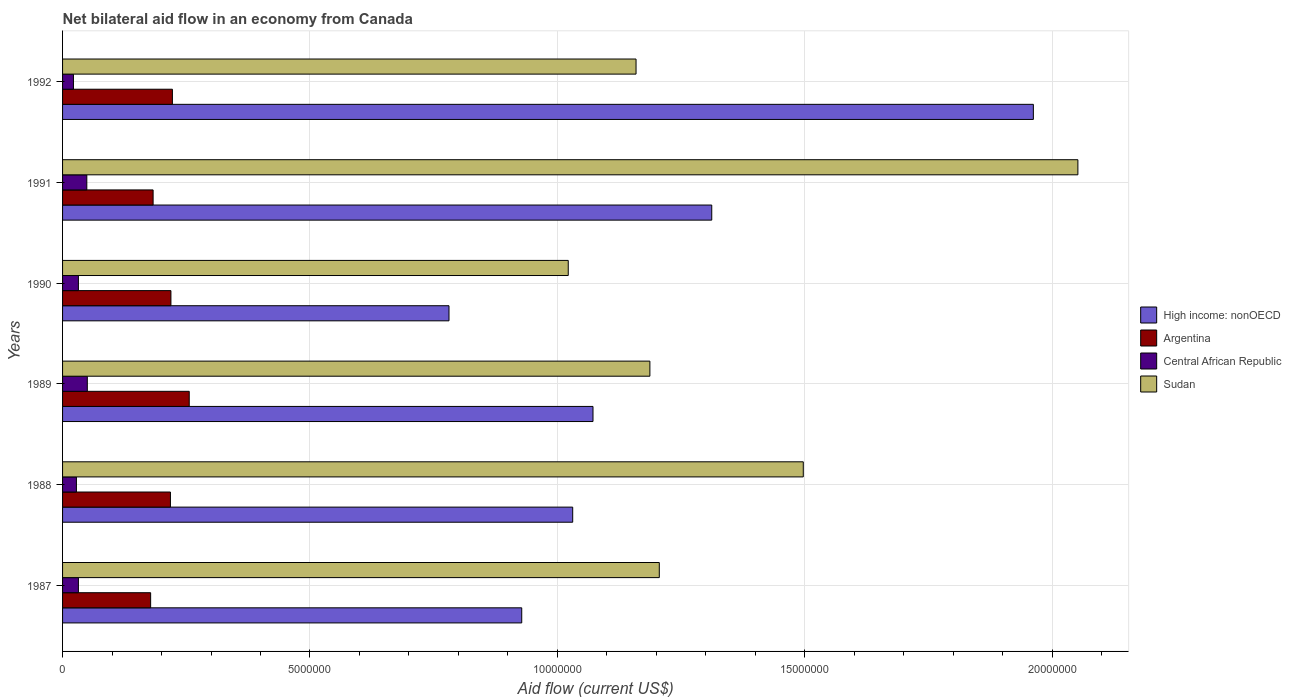How many groups of bars are there?
Give a very brief answer. 6. Are the number of bars on each tick of the Y-axis equal?
Provide a short and direct response. Yes. How many bars are there on the 3rd tick from the top?
Ensure brevity in your answer.  4. How many bars are there on the 4th tick from the bottom?
Offer a very short reply. 4. What is the label of the 2nd group of bars from the top?
Keep it short and to the point. 1991. In how many cases, is the number of bars for a given year not equal to the number of legend labels?
Provide a short and direct response. 0. Across all years, what is the maximum net bilateral aid flow in Sudan?
Make the answer very short. 2.05e+07. Across all years, what is the minimum net bilateral aid flow in Argentina?
Your response must be concise. 1.78e+06. In which year was the net bilateral aid flow in High income: nonOECD maximum?
Make the answer very short. 1992. What is the total net bilateral aid flow in Central African Republic in the graph?
Ensure brevity in your answer.  2.13e+06. What is the difference between the net bilateral aid flow in High income: nonOECD in 1987 and that in 1988?
Ensure brevity in your answer.  -1.03e+06. What is the difference between the net bilateral aid flow in Argentina in 1987 and the net bilateral aid flow in Sudan in 1988?
Ensure brevity in your answer.  -1.32e+07. What is the average net bilateral aid flow in Central African Republic per year?
Provide a short and direct response. 3.55e+05. In the year 1989, what is the difference between the net bilateral aid flow in High income: nonOECD and net bilateral aid flow in Argentina?
Your answer should be very brief. 8.16e+06. In how many years, is the net bilateral aid flow in Argentina greater than 5000000 US$?
Make the answer very short. 0. What is the ratio of the net bilateral aid flow in Sudan in 1988 to that in 1989?
Your answer should be compact. 1.26. Is the net bilateral aid flow in Sudan in 1987 less than that in 1992?
Offer a terse response. No. What is the difference between the highest and the second highest net bilateral aid flow in Sudan?
Offer a very short reply. 5.55e+06. What is the difference between the highest and the lowest net bilateral aid flow in Central African Republic?
Offer a very short reply. 2.80e+05. In how many years, is the net bilateral aid flow in Argentina greater than the average net bilateral aid flow in Argentina taken over all years?
Provide a succinct answer. 4. Is the sum of the net bilateral aid flow in Central African Republic in 1987 and 1991 greater than the maximum net bilateral aid flow in Sudan across all years?
Offer a very short reply. No. What does the 3rd bar from the bottom in 1991 represents?
Ensure brevity in your answer.  Central African Republic. How many years are there in the graph?
Make the answer very short. 6. Are the values on the major ticks of X-axis written in scientific E-notation?
Offer a terse response. No. What is the title of the graph?
Offer a very short reply. Net bilateral aid flow in an economy from Canada. What is the label or title of the Y-axis?
Make the answer very short. Years. What is the Aid flow (current US$) of High income: nonOECD in 1987?
Your answer should be very brief. 9.28e+06. What is the Aid flow (current US$) in Argentina in 1987?
Provide a short and direct response. 1.78e+06. What is the Aid flow (current US$) in Sudan in 1987?
Ensure brevity in your answer.  1.21e+07. What is the Aid flow (current US$) of High income: nonOECD in 1988?
Your answer should be compact. 1.03e+07. What is the Aid flow (current US$) of Argentina in 1988?
Your answer should be very brief. 2.18e+06. What is the Aid flow (current US$) of Central African Republic in 1988?
Your answer should be very brief. 2.80e+05. What is the Aid flow (current US$) in Sudan in 1988?
Provide a succinct answer. 1.50e+07. What is the Aid flow (current US$) in High income: nonOECD in 1989?
Give a very brief answer. 1.07e+07. What is the Aid flow (current US$) of Argentina in 1989?
Provide a short and direct response. 2.56e+06. What is the Aid flow (current US$) in Sudan in 1989?
Keep it short and to the point. 1.19e+07. What is the Aid flow (current US$) in High income: nonOECD in 1990?
Your answer should be compact. 7.81e+06. What is the Aid flow (current US$) of Argentina in 1990?
Provide a short and direct response. 2.19e+06. What is the Aid flow (current US$) in Central African Republic in 1990?
Offer a terse response. 3.20e+05. What is the Aid flow (current US$) in Sudan in 1990?
Ensure brevity in your answer.  1.02e+07. What is the Aid flow (current US$) in High income: nonOECD in 1991?
Your answer should be very brief. 1.31e+07. What is the Aid flow (current US$) of Argentina in 1991?
Give a very brief answer. 1.83e+06. What is the Aid flow (current US$) in Sudan in 1991?
Provide a short and direct response. 2.05e+07. What is the Aid flow (current US$) in High income: nonOECD in 1992?
Offer a very short reply. 1.96e+07. What is the Aid flow (current US$) in Argentina in 1992?
Ensure brevity in your answer.  2.22e+06. What is the Aid flow (current US$) in Sudan in 1992?
Your response must be concise. 1.16e+07. Across all years, what is the maximum Aid flow (current US$) in High income: nonOECD?
Your answer should be very brief. 1.96e+07. Across all years, what is the maximum Aid flow (current US$) of Argentina?
Keep it short and to the point. 2.56e+06. Across all years, what is the maximum Aid flow (current US$) of Central African Republic?
Your response must be concise. 5.00e+05. Across all years, what is the maximum Aid flow (current US$) in Sudan?
Give a very brief answer. 2.05e+07. Across all years, what is the minimum Aid flow (current US$) of High income: nonOECD?
Your answer should be very brief. 7.81e+06. Across all years, what is the minimum Aid flow (current US$) in Argentina?
Offer a terse response. 1.78e+06. Across all years, what is the minimum Aid flow (current US$) of Central African Republic?
Provide a succinct answer. 2.20e+05. Across all years, what is the minimum Aid flow (current US$) of Sudan?
Keep it short and to the point. 1.02e+07. What is the total Aid flow (current US$) in High income: nonOECD in the graph?
Provide a short and direct response. 7.09e+07. What is the total Aid flow (current US$) in Argentina in the graph?
Give a very brief answer. 1.28e+07. What is the total Aid flow (current US$) of Central African Republic in the graph?
Your answer should be compact. 2.13e+06. What is the total Aid flow (current US$) in Sudan in the graph?
Your answer should be very brief. 8.12e+07. What is the difference between the Aid flow (current US$) in High income: nonOECD in 1987 and that in 1988?
Provide a short and direct response. -1.03e+06. What is the difference between the Aid flow (current US$) of Argentina in 1987 and that in 1988?
Your answer should be very brief. -4.00e+05. What is the difference between the Aid flow (current US$) in Sudan in 1987 and that in 1988?
Keep it short and to the point. -2.91e+06. What is the difference between the Aid flow (current US$) of High income: nonOECD in 1987 and that in 1989?
Give a very brief answer. -1.44e+06. What is the difference between the Aid flow (current US$) of Argentina in 1987 and that in 1989?
Offer a terse response. -7.80e+05. What is the difference between the Aid flow (current US$) of Central African Republic in 1987 and that in 1989?
Provide a short and direct response. -1.80e+05. What is the difference between the Aid flow (current US$) in High income: nonOECD in 1987 and that in 1990?
Ensure brevity in your answer.  1.47e+06. What is the difference between the Aid flow (current US$) of Argentina in 1987 and that in 1990?
Ensure brevity in your answer.  -4.10e+05. What is the difference between the Aid flow (current US$) in Sudan in 1987 and that in 1990?
Offer a terse response. 1.84e+06. What is the difference between the Aid flow (current US$) of High income: nonOECD in 1987 and that in 1991?
Provide a succinct answer. -3.84e+06. What is the difference between the Aid flow (current US$) in Argentina in 1987 and that in 1991?
Ensure brevity in your answer.  -5.00e+04. What is the difference between the Aid flow (current US$) of Sudan in 1987 and that in 1991?
Your answer should be very brief. -8.46e+06. What is the difference between the Aid flow (current US$) in High income: nonOECD in 1987 and that in 1992?
Offer a terse response. -1.03e+07. What is the difference between the Aid flow (current US$) in Argentina in 1987 and that in 1992?
Your answer should be very brief. -4.40e+05. What is the difference between the Aid flow (current US$) of Central African Republic in 1987 and that in 1992?
Offer a very short reply. 1.00e+05. What is the difference between the Aid flow (current US$) in High income: nonOECD in 1988 and that in 1989?
Offer a terse response. -4.10e+05. What is the difference between the Aid flow (current US$) in Argentina in 1988 and that in 1989?
Your answer should be compact. -3.80e+05. What is the difference between the Aid flow (current US$) of Sudan in 1988 and that in 1989?
Offer a very short reply. 3.10e+06. What is the difference between the Aid flow (current US$) of High income: nonOECD in 1988 and that in 1990?
Offer a very short reply. 2.50e+06. What is the difference between the Aid flow (current US$) of Argentina in 1988 and that in 1990?
Keep it short and to the point. -10000. What is the difference between the Aid flow (current US$) of Sudan in 1988 and that in 1990?
Make the answer very short. 4.75e+06. What is the difference between the Aid flow (current US$) of High income: nonOECD in 1988 and that in 1991?
Give a very brief answer. -2.81e+06. What is the difference between the Aid flow (current US$) in Argentina in 1988 and that in 1991?
Provide a short and direct response. 3.50e+05. What is the difference between the Aid flow (current US$) of Sudan in 1988 and that in 1991?
Offer a terse response. -5.55e+06. What is the difference between the Aid flow (current US$) in High income: nonOECD in 1988 and that in 1992?
Your answer should be compact. -9.31e+06. What is the difference between the Aid flow (current US$) of Argentina in 1988 and that in 1992?
Your response must be concise. -4.00e+04. What is the difference between the Aid flow (current US$) in Sudan in 1988 and that in 1992?
Keep it short and to the point. 3.38e+06. What is the difference between the Aid flow (current US$) in High income: nonOECD in 1989 and that in 1990?
Ensure brevity in your answer.  2.91e+06. What is the difference between the Aid flow (current US$) in Argentina in 1989 and that in 1990?
Provide a short and direct response. 3.70e+05. What is the difference between the Aid flow (current US$) in Sudan in 1989 and that in 1990?
Make the answer very short. 1.65e+06. What is the difference between the Aid flow (current US$) in High income: nonOECD in 1989 and that in 1991?
Ensure brevity in your answer.  -2.40e+06. What is the difference between the Aid flow (current US$) of Argentina in 1989 and that in 1991?
Keep it short and to the point. 7.30e+05. What is the difference between the Aid flow (current US$) in Sudan in 1989 and that in 1991?
Keep it short and to the point. -8.65e+06. What is the difference between the Aid flow (current US$) of High income: nonOECD in 1989 and that in 1992?
Provide a short and direct response. -8.90e+06. What is the difference between the Aid flow (current US$) of Sudan in 1989 and that in 1992?
Provide a succinct answer. 2.80e+05. What is the difference between the Aid flow (current US$) of High income: nonOECD in 1990 and that in 1991?
Your response must be concise. -5.31e+06. What is the difference between the Aid flow (current US$) of Central African Republic in 1990 and that in 1991?
Provide a succinct answer. -1.70e+05. What is the difference between the Aid flow (current US$) of Sudan in 1990 and that in 1991?
Make the answer very short. -1.03e+07. What is the difference between the Aid flow (current US$) of High income: nonOECD in 1990 and that in 1992?
Keep it short and to the point. -1.18e+07. What is the difference between the Aid flow (current US$) of Argentina in 1990 and that in 1992?
Give a very brief answer. -3.00e+04. What is the difference between the Aid flow (current US$) of Central African Republic in 1990 and that in 1992?
Provide a short and direct response. 1.00e+05. What is the difference between the Aid flow (current US$) in Sudan in 1990 and that in 1992?
Offer a terse response. -1.37e+06. What is the difference between the Aid flow (current US$) of High income: nonOECD in 1991 and that in 1992?
Offer a terse response. -6.50e+06. What is the difference between the Aid flow (current US$) of Argentina in 1991 and that in 1992?
Your response must be concise. -3.90e+05. What is the difference between the Aid flow (current US$) of Central African Republic in 1991 and that in 1992?
Keep it short and to the point. 2.70e+05. What is the difference between the Aid flow (current US$) of Sudan in 1991 and that in 1992?
Provide a succinct answer. 8.93e+06. What is the difference between the Aid flow (current US$) of High income: nonOECD in 1987 and the Aid flow (current US$) of Argentina in 1988?
Make the answer very short. 7.10e+06. What is the difference between the Aid flow (current US$) of High income: nonOECD in 1987 and the Aid flow (current US$) of Central African Republic in 1988?
Offer a terse response. 9.00e+06. What is the difference between the Aid flow (current US$) of High income: nonOECD in 1987 and the Aid flow (current US$) of Sudan in 1988?
Offer a terse response. -5.69e+06. What is the difference between the Aid flow (current US$) of Argentina in 1987 and the Aid flow (current US$) of Central African Republic in 1988?
Offer a terse response. 1.50e+06. What is the difference between the Aid flow (current US$) in Argentina in 1987 and the Aid flow (current US$) in Sudan in 1988?
Your response must be concise. -1.32e+07. What is the difference between the Aid flow (current US$) in Central African Republic in 1987 and the Aid flow (current US$) in Sudan in 1988?
Keep it short and to the point. -1.46e+07. What is the difference between the Aid flow (current US$) of High income: nonOECD in 1987 and the Aid flow (current US$) of Argentina in 1989?
Offer a very short reply. 6.72e+06. What is the difference between the Aid flow (current US$) of High income: nonOECD in 1987 and the Aid flow (current US$) of Central African Republic in 1989?
Your answer should be very brief. 8.78e+06. What is the difference between the Aid flow (current US$) of High income: nonOECD in 1987 and the Aid flow (current US$) of Sudan in 1989?
Give a very brief answer. -2.59e+06. What is the difference between the Aid flow (current US$) of Argentina in 1987 and the Aid flow (current US$) of Central African Republic in 1989?
Your answer should be very brief. 1.28e+06. What is the difference between the Aid flow (current US$) of Argentina in 1987 and the Aid flow (current US$) of Sudan in 1989?
Make the answer very short. -1.01e+07. What is the difference between the Aid flow (current US$) of Central African Republic in 1987 and the Aid flow (current US$) of Sudan in 1989?
Your answer should be very brief. -1.16e+07. What is the difference between the Aid flow (current US$) of High income: nonOECD in 1987 and the Aid flow (current US$) of Argentina in 1990?
Make the answer very short. 7.09e+06. What is the difference between the Aid flow (current US$) in High income: nonOECD in 1987 and the Aid flow (current US$) in Central African Republic in 1990?
Your response must be concise. 8.96e+06. What is the difference between the Aid flow (current US$) of High income: nonOECD in 1987 and the Aid flow (current US$) of Sudan in 1990?
Ensure brevity in your answer.  -9.40e+05. What is the difference between the Aid flow (current US$) in Argentina in 1987 and the Aid flow (current US$) in Central African Republic in 1990?
Keep it short and to the point. 1.46e+06. What is the difference between the Aid flow (current US$) in Argentina in 1987 and the Aid flow (current US$) in Sudan in 1990?
Keep it short and to the point. -8.44e+06. What is the difference between the Aid flow (current US$) in Central African Republic in 1987 and the Aid flow (current US$) in Sudan in 1990?
Provide a short and direct response. -9.90e+06. What is the difference between the Aid flow (current US$) of High income: nonOECD in 1987 and the Aid flow (current US$) of Argentina in 1991?
Ensure brevity in your answer.  7.45e+06. What is the difference between the Aid flow (current US$) of High income: nonOECD in 1987 and the Aid flow (current US$) of Central African Republic in 1991?
Make the answer very short. 8.79e+06. What is the difference between the Aid flow (current US$) in High income: nonOECD in 1987 and the Aid flow (current US$) in Sudan in 1991?
Your answer should be compact. -1.12e+07. What is the difference between the Aid flow (current US$) in Argentina in 1987 and the Aid flow (current US$) in Central African Republic in 1991?
Keep it short and to the point. 1.29e+06. What is the difference between the Aid flow (current US$) in Argentina in 1987 and the Aid flow (current US$) in Sudan in 1991?
Keep it short and to the point. -1.87e+07. What is the difference between the Aid flow (current US$) of Central African Republic in 1987 and the Aid flow (current US$) of Sudan in 1991?
Offer a terse response. -2.02e+07. What is the difference between the Aid flow (current US$) in High income: nonOECD in 1987 and the Aid flow (current US$) in Argentina in 1992?
Make the answer very short. 7.06e+06. What is the difference between the Aid flow (current US$) in High income: nonOECD in 1987 and the Aid flow (current US$) in Central African Republic in 1992?
Ensure brevity in your answer.  9.06e+06. What is the difference between the Aid flow (current US$) of High income: nonOECD in 1987 and the Aid flow (current US$) of Sudan in 1992?
Offer a terse response. -2.31e+06. What is the difference between the Aid flow (current US$) in Argentina in 1987 and the Aid flow (current US$) in Central African Republic in 1992?
Your answer should be compact. 1.56e+06. What is the difference between the Aid flow (current US$) in Argentina in 1987 and the Aid flow (current US$) in Sudan in 1992?
Make the answer very short. -9.81e+06. What is the difference between the Aid flow (current US$) in Central African Republic in 1987 and the Aid flow (current US$) in Sudan in 1992?
Offer a terse response. -1.13e+07. What is the difference between the Aid flow (current US$) of High income: nonOECD in 1988 and the Aid flow (current US$) of Argentina in 1989?
Give a very brief answer. 7.75e+06. What is the difference between the Aid flow (current US$) in High income: nonOECD in 1988 and the Aid flow (current US$) in Central African Republic in 1989?
Your answer should be compact. 9.81e+06. What is the difference between the Aid flow (current US$) of High income: nonOECD in 1988 and the Aid flow (current US$) of Sudan in 1989?
Provide a succinct answer. -1.56e+06. What is the difference between the Aid flow (current US$) in Argentina in 1988 and the Aid flow (current US$) in Central African Republic in 1989?
Keep it short and to the point. 1.68e+06. What is the difference between the Aid flow (current US$) of Argentina in 1988 and the Aid flow (current US$) of Sudan in 1989?
Provide a short and direct response. -9.69e+06. What is the difference between the Aid flow (current US$) of Central African Republic in 1988 and the Aid flow (current US$) of Sudan in 1989?
Make the answer very short. -1.16e+07. What is the difference between the Aid flow (current US$) in High income: nonOECD in 1988 and the Aid flow (current US$) in Argentina in 1990?
Provide a short and direct response. 8.12e+06. What is the difference between the Aid flow (current US$) in High income: nonOECD in 1988 and the Aid flow (current US$) in Central African Republic in 1990?
Ensure brevity in your answer.  9.99e+06. What is the difference between the Aid flow (current US$) in High income: nonOECD in 1988 and the Aid flow (current US$) in Sudan in 1990?
Your answer should be very brief. 9.00e+04. What is the difference between the Aid flow (current US$) of Argentina in 1988 and the Aid flow (current US$) of Central African Republic in 1990?
Make the answer very short. 1.86e+06. What is the difference between the Aid flow (current US$) in Argentina in 1988 and the Aid flow (current US$) in Sudan in 1990?
Provide a short and direct response. -8.04e+06. What is the difference between the Aid flow (current US$) of Central African Republic in 1988 and the Aid flow (current US$) of Sudan in 1990?
Offer a very short reply. -9.94e+06. What is the difference between the Aid flow (current US$) in High income: nonOECD in 1988 and the Aid flow (current US$) in Argentina in 1991?
Your answer should be very brief. 8.48e+06. What is the difference between the Aid flow (current US$) in High income: nonOECD in 1988 and the Aid flow (current US$) in Central African Republic in 1991?
Keep it short and to the point. 9.82e+06. What is the difference between the Aid flow (current US$) in High income: nonOECD in 1988 and the Aid flow (current US$) in Sudan in 1991?
Keep it short and to the point. -1.02e+07. What is the difference between the Aid flow (current US$) of Argentina in 1988 and the Aid flow (current US$) of Central African Republic in 1991?
Offer a very short reply. 1.69e+06. What is the difference between the Aid flow (current US$) of Argentina in 1988 and the Aid flow (current US$) of Sudan in 1991?
Offer a terse response. -1.83e+07. What is the difference between the Aid flow (current US$) of Central African Republic in 1988 and the Aid flow (current US$) of Sudan in 1991?
Provide a succinct answer. -2.02e+07. What is the difference between the Aid flow (current US$) in High income: nonOECD in 1988 and the Aid flow (current US$) in Argentina in 1992?
Offer a terse response. 8.09e+06. What is the difference between the Aid flow (current US$) in High income: nonOECD in 1988 and the Aid flow (current US$) in Central African Republic in 1992?
Offer a very short reply. 1.01e+07. What is the difference between the Aid flow (current US$) of High income: nonOECD in 1988 and the Aid flow (current US$) of Sudan in 1992?
Keep it short and to the point. -1.28e+06. What is the difference between the Aid flow (current US$) in Argentina in 1988 and the Aid flow (current US$) in Central African Republic in 1992?
Your answer should be very brief. 1.96e+06. What is the difference between the Aid flow (current US$) in Argentina in 1988 and the Aid flow (current US$) in Sudan in 1992?
Offer a very short reply. -9.41e+06. What is the difference between the Aid flow (current US$) of Central African Republic in 1988 and the Aid flow (current US$) of Sudan in 1992?
Provide a short and direct response. -1.13e+07. What is the difference between the Aid flow (current US$) in High income: nonOECD in 1989 and the Aid flow (current US$) in Argentina in 1990?
Offer a terse response. 8.53e+06. What is the difference between the Aid flow (current US$) of High income: nonOECD in 1989 and the Aid flow (current US$) of Central African Republic in 1990?
Ensure brevity in your answer.  1.04e+07. What is the difference between the Aid flow (current US$) of Argentina in 1989 and the Aid flow (current US$) of Central African Republic in 1990?
Provide a short and direct response. 2.24e+06. What is the difference between the Aid flow (current US$) of Argentina in 1989 and the Aid flow (current US$) of Sudan in 1990?
Make the answer very short. -7.66e+06. What is the difference between the Aid flow (current US$) in Central African Republic in 1989 and the Aid flow (current US$) in Sudan in 1990?
Offer a very short reply. -9.72e+06. What is the difference between the Aid flow (current US$) in High income: nonOECD in 1989 and the Aid flow (current US$) in Argentina in 1991?
Offer a very short reply. 8.89e+06. What is the difference between the Aid flow (current US$) in High income: nonOECD in 1989 and the Aid flow (current US$) in Central African Republic in 1991?
Provide a succinct answer. 1.02e+07. What is the difference between the Aid flow (current US$) of High income: nonOECD in 1989 and the Aid flow (current US$) of Sudan in 1991?
Your answer should be very brief. -9.80e+06. What is the difference between the Aid flow (current US$) in Argentina in 1989 and the Aid flow (current US$) in Central African Republic in 1991?
Your answer should be compact. 2.07e+06. What is the difference between the Aid flow (current US$) of Argentina in 1989 and the Aid flow (current US$) of Sudan in 1991?
Your response must be concise. -1.80e+07. What is the difference between the Aid flow (current US$) of Central African Republic in 1989 and the Aid flow (current US$) of Sudan in 1991?
Ensure brevity in your answer.  -2.00e+07. What is the difference between the Aid flow (current US$) of High income: nonOECD in 1989 and the Aid flow (current US$) of Argentina in 1992?
Make the answer very short. 8.50e+06. What is the difference between the Aid flow (current US$) in High income: nonOECD in 1989 and the Aid flow (current US$) in Central African Republic in 1992?
Offer a terse response. 1.05e+07. What is the difference between the Aid flow (current US$) in High income: nonOECD in 1989 and the Aid flow (current US$) in Sudan in 1992?
Give a very brief answer. -8.70e+05. What is the difference between the Aid flow (current US$) of Argentina in 1989 and the Aid flow (current US$) of Central African Republic in 1992?
Make the answer very short. 2.34e+06. What is the difference between the Aid flow (current US$) in Argentina in 1989 and the Aid flow (current US$) in Sudan in 1992?
Your answer should be very brief. -9.03e+06. What is the difference between the Aid flow (current US$) in Central African Republic in 1989 and the Aid flow (current US$) in Sudan in 1992?
Make the answer very short. -1.11e+07. What is the difference between the Aid flow (current US$) of High income: nonOECD in 1990 and the Aid flow (current US$) of Argentina in 1991?
Offer a terse response. 5.98e+06. What is the difference between the Aid flow (current US$) in High income: nonOECD in 1990 and the Aid flow (current US$) in Central African Republic in 1991?
Offer a very short reply. 7.32e+06. What is the difference between the Aid flow (current US$) of High income: nonOECD in 1990 and the Aid flow (current US$) of Sudan in 1991?
Your response must be concise. -1.27e+07. What is the difference between the Aid flow (current US$) in Argentina in 1990 and the Aid flow (current US$) in Central African Republic in 1991?
Give a very brief answer. 1.70e+06. What is the difference between the Aid flow (current US$) in Argentina in 1990 and the Aid flow (current US$) in Sudan in 1991?
Ensure brevity in your answer.  -1.83e+07. What is the difference between the Aid flow (current US$) of Central African Republic in 1990 and the Aid flow (current US$) of Sudan in 1991?
Make the answer very short. -2.02e+07. What is the difference between the Aid flow (current US$) in High income: nonOECD in 1990 and the Aid flow (current US$) in Argentina in 1992?
Make the answer very short. 5.59e+06. What is the difference between the Aid flow (current US$) in High income: nonOECD in 1990 and the Aid flow (current US$) in Central African Republic in 1992?
Your response must be concise. 7.59e+06. What is the difference between the Aid flow (current US$) in High income: nonOECD in 1990 and the Aid flow (current US$) in Sudan in 1992?
Provide a short and direct response. -3.78e+06. What is the difference between the Aid flow (current US$) of Argentina in 1990 and the Aid flow (current US$) of Central African Republic in 1992?
Your response must be concise. 1.97e+06. What is the difference between the Aid flow (current US$) in Argentina in 1990 and the Aid flow (current US$) in Sudan in 1992?
Give a very brief answer. -9.40e+06. What is the difference between the Aid flow (current US$) in Central African Republic in 1990 and the Aid flow (current US$) in Sudan in 1992?
Make the answer very short. -1.13e+07. What is the difference between the Aid flow (current US$) of High income: nonOECD in 1991 and the Aid flow (current US$) of Argentina in 1992?
Give a very brief answer. 1.09e+07. What is the difference between the Aid flow (current US$) in High income: nonOECD in 1991 and the Aid flow (current US$) in Central African Republic in 1992?
Give a very brief answer. 1.29e+07. What is the difference between the Aid flow (current US$) of High income: nonOECD in 1991 and the Aid flow (current US$) of Sudan in 1992?
Make the answer very short. 1.53e+06. What is the difference between the Aid flow (current US$) of Argentina in 1991 and the Aid flow (current US$) of Central African Republic in 1992?
Keep it short and to the point. 1.61e+06. What is the difference between the Aid flow (current US$) of Argentina in 1991 and the Aid flow (current US$) of Sudan in 1992?
Make the answer very short. -9.76e+06. What is the difference between the Aid flow (current US$) of Central African Republic in 1991 and the Aid flow (current US$) of Sudan in 1992?
Your answer should be very brief. -1.11e+07. What is the average Aid flow (current US$) of High income: nonOECD per year?
Keep it short and to the point. 1.18e+07. What is the average Aid flow (current US$) of Argentina per year?
Give a very brief answer. 2.13e+06. What is the average Aid flow (current US$) of Central African Republic per year?
Your answer should be compact. 3.55e+05. What is the average Aid flow (current US$) in Sudan per year?
Keep it short and to the point. 1.35e+07. In the year 1987, what is the difference between the Aid flow (current US$) in High income: nonOECD and Aid flow (current US$) in Argentina?
Give a very brief answer. 7.50e+06. In the year 1987, what is the difference between the Aid flow (current US$) of High income: nonOECD and Aid flow (current US$) of Central African Republic?
Your response must be concise. 8.96e+06. In the year 1987, what is the difference between the Aid flow (current US$) in High income: nonOECD and Aid flow (current US$) in Sudan?
Offer a terse response. -2.78e+06. In the year 1987, what is the difference between the Aid flow (current US$) in Argentina and Aid flow (current US$) in Central African Republic?
Make the answer very short. 1.46e+06. In the year 1987, what is the difference between the Aid flow (current US$) of Argentina and Aid flow (current US$) of Sudan?
Offer a terse response. -1.03e+07. In the year 1987, what is the difference between the Aid flow (current US$) in Central African Republic and Aid flow (current US$) in Sudan?
Ensure brevity in your answer.  -1.17e+07. In the year 1988, what is the difference between the Aid flow (current US$) of High income: nonOECD and Aid flow (current US$) of Argentina?
Your response must be concise. 8.13e+06. In the year 1988, what is the difference between the Aid flow (current US$) in High income: nonOECD and Aid flow (current US$) in Central African Republic?
Ensure brevity in your answer.  1.00e+07. In the year 1988, what is the difference between the Aid flow (current US$) in High income: nonOECD and Aid flow (current US$) in Sudan?
Your answer should be very brief. -4.66e+06. In the year 1988, what is the difference between the Aid flow (current US$) in Argentina and Aid flow (current US$) in Central African Republic?
Give a very brief answer. 1.90e+06. In the year 1988, what is the difference between the Aid flow (current US$) of Argentina and Aid flow (current US$) of Sudan?
Your answer should be very brief. -1.28e+07. In the year 1988, what is the difference between the Aid flow (current US$) in Central African Republic and Aid flow (current US$) in Sudan?
Offer a terse response. -1.47e+07. In the year 1989, what is the difference between the Aid flow (current US$) of High income: nonOECD and Aid flow (current US$) of Argentina?
Your response must be concise. 8.16e+06. In the year 1989, what is the difference between the Aid flow (current US$) in High income: nonOECD and Aid flow (current US$) in Central African Republic?
Keep it short and to the point. 1.02e+07. In the year 1989, what is the difference between the Aid flow (current US$) in High income: nonOECD and Aid flow (current US$) in Sudan?
Ensure brevity in your answer.  -1.15e+06. In the year 1989, what is the difference between the Aid flow (current US$) in Argentina and Aid flow (current US$) in Central African Republic?
Provide a succinct answer. 2.06e+06. In the year 1989, what is the difference between the Aid flow (current US$) of Argentina and Aid flow (current US$) of Sudan?
Your response must be concise. -9.31e+06. In the year 1989, what is the difference between the Aid flow (current US$) in Central African Republic and Aid flow (current US$) in Sudan?
Make the answer very short. -1.14e+07. In the year 1990, what is the difference between the Aid flow (current US$) in High income: nonOECD and Aid flow (current US$) in Argentina?
Offer a very short reply. 5.62e+06. In the year 1990, what is the difference between the Aid flow (current US$) in High income: nonOECD and Aid flow (current US$) in Central African Republic?
Offer a very short reply. 7.49e+06. In the year 1990, what is the difference between the Aid flow (current US$) of High income: nonOECD and Aid flow (current US$) of Sudan?
Your response must be concise. -2.41e+06. In the year 1990, what is the difference between the Aid flow (current US$) in Argentina and Aid flow (current US$) in Central African Republic?
Offer a very short reply. 1.87e+06. In the year 1990, what is the difference between the Aid flow (current US$) in Argentina and Aid flow (current US$) in Sudan?
Provide a short and direct response. -8.03e+06. In the year 1990, what is the difference between the Aid flow (current US$) of Central African Republic and Aid flow (current US$) of Sudan?
Make the answer very short. -9.90e+06. In the year 1991, what is the difference between the Aid flow (current US$) of High income: nonOECD and Aid flow (current US$) of Argentina?
Make the answer very short. 1.13e+07. In the year 1991, what is the difference between the Aid flow (current US$) in High income: nonOECD and Aid flow (current US$) in Central African Republic?
Provide a succinct answer. 1.26e+07. In the year 1991, what is the difference between the Aid flow (current US$) of High income: nonOECD and Aid flow (current US$) of Sudan?
Your answer should be very brief. -7.40e+06. In the year 1991, what is the difference between the Aid flow (current US$) of Argentina and Aid flow (current US$) of Central African Republic?
Offer a very short reply. 1.34e+06. In the year 1991, what is the difference between the Aid flow (current US$) of Argentina and Aid flow (current US$) of Sudan?
Provide a short and direct response. -1.87e+07. In the year 1991, what is the difference between the Aid flow (current US$) of Central African Republic and Aid flow (current US$) of Sudan?
Provide a succinct answer. -2.00e+07. In the year 1992, what is the difference between the Aid flow (current US$) in High income: nonOECD and Aid flow (current US$) in Argentina?
Keep it short and to the point. 1.74e+07. In the year 1992, what is the difference between the Aid flow (current US$) in High income: nonOECD and Aid flow (current US$) in Central African Republic?
Ensure brevity in your answer.  1.94e+07. In the year 1992, what is the difference between the Aid flow (current US$) of High income: nonOECD and Aid flow (current US$) of Sudan?
Provide a short and direct response. 8.03e+06. In the year 1992, what is the difference between the Aid flow (current US$) in Argentina and Aid flow (current US$) in Central African Republic?
Your answer should be very brief. 2.00e+06. In the year 1992, what is the difference between the Aid flow (current US$) in Argentina and Aid flow (current US$) in Sudan?
Keep it short and to the point. -9.37e+06. In the year 1992, what is the difference between the Aid flow (current US$) in Central African Republic and Aid flow (current US$) in Sudan?
Offer a terse response. -1.14e+07. What is the ratio of the Aid flow (current US$) of High income: nonOECD in 1987 to that in 1988?
Ensure brevity in your answer.  0.9. What is the ratio of the Aid flow (current US$) of Argentina in 1987 to that in 1988?
Provide a short and direct response. 0.82. What is the ratio of the Aid flow (current US$) of Central African Republic in 1987 to that in 1988?
Offer a very short reply. 1.14. What is the ratio of the Aid flow (current US$) in Sudan in 1987 to that in 1988?
Your answer should be compact. 0.81. What is the ratio of the Aid flow (current US$) in High income: nonOECD in 1987 to that in 1989?
Ensure brevity in your answer.  0.87. What is the ratio of the Aid flow (current US$) of Argentina in 1987 to that in 1989?
Your response must be concise. 0.7. What is the ratio of the Aid flow (current US$) of Central African Republic in 1987 to that in 1989?
Ensure brevity in your answer.  0.64. What is the ratio of the Aid flow (current US$) of Sudan in 1987 to that in 1989?
Your response must be concise. 1.02. What is the ratio of the Aid flow (current US$) in High income: nonOECD in 1987 to that in 1990?
Your response must be concise. 1.19. What is the ratio of the Aid flow (current US$) in Argentina in 1987 to that in 1990?
Keep it short and to the point. 0.81. What is the ratio of the Aid flow (current US$) in Central African Republic in 1987 to that in 1990?
Provide a succinct answer. 1. What is the ratio of the Aid flow (current US$) of Sudan in 1987 to that in 1990?
Offer a very short reply. 1.18. What is the ratio of the Aid flow (current US$) in High income: nonOECD in 1987 to that in 1991?
Offer a very short reply. 0.71. What is the ratio of the Aid flow (current US$) in Argentina in 1987 to that in 1991?
Keep it short and to the point. 0.97. What is the ratio of the Aid flow (current US$) in Central African Republic in 1987 to that in 1991?
Offer a terse response. 0.65. What is the ratio of the Aid flow (current US$) of Sudan in 1987 to that in 1991?
Give a very brief answer. 0.59. What is the ratio of the Aid flow (current US$) of High income: nonOECD in 1987 to that in 1992?
Offer a very short reply. 0.47. What is the ratio of the Aid flow (current US$) in Argentina in 1987 to that in 1992?
Your answer should be very brief. 0.8. What is the ratio of the Aid flow (current US$) in Central African Republic in 1987 to that in 1992?
Offer a terse response. 1.45. What is the ratio of the Aid flow (current US$) in Sudan in 1987 to that in 1992?
Offer a terse response. 1.04. What is the ratio of the Aid flow (current US$) in High income: nonOECD in 1988 to that in 1989?
Offer a very short reply. 0.96. What is the ratio of the Aid flow (current US$) in Argentina in 1988 to that in 1989?
Your response must be concise. 0.85. What is the ratio of the Aid flow (current US$) in Central African Republic in 1988 to that in 1989?
Your answer should be compact. 0.56. What is the ratio of the Aid flow (current US$) of Sudan in 1988 to that in 1989?
Ensure brevity in your answer.  1.26. What is the ratio of the Aid flow (current US$) in High income: nonOECD in 1988 to that in 1990?
Your answer should be compact. 1.32. What is the ratio of the Aid flow (current US$) of Argentina in 1988 to that in 1990?
Your answer should be very brief. 1. What is the ratio of the Aid flow (current US$) in Sudan in 1988 to that in 1990?
Keep it short and to the point. 1.46. What is the ratio of the Aid flow (current US$) in High income: nonOECD in 1988 to that in 1991?
Your response must be concise. 0.79. What is the ratio of the Aid flow (current US$) in Argentina in 1988 to that in 1991?
Provide a succinct answer. 1.19. What is the ratio of the Aid flow (current US$) of Sudan in 1988 to that in 1991?
Your answer should be very brief. 0.73. What is the ratio of the Aid flow (current US$) in High income: nonOECD in 1988 to that in 1992?
Ensure brevity in your answer.  0.53. What is the ratio of the Aid flow (current US$) of Central African Republic in 1988 to that in 1992?
Offer a very short reply. 1.27. What is the ratio of the Aid flow (current US$) of Sudan in 1988 to that in 1992?
Offer a very short reply. 1.29. What is the ratio of the Aid flow (current US$) of High income: nonOECD in 1989 to that in 1990?
Make the answer very short. 1.37. What is the ratio of the Aid flow (current US$) of Argentina in 1989 to that in 1990?
Your answer should be compact. 1.17. What is the ratio of the Aid flow (current US$) of Central African Republic in 1989 to that in 1990?
Ensure brevity in your answer.  1.56. What is the ratio of the Aid flow (current US$) of Sudan in 1989 to that in 1990?
Offer a very short reply. 1.16. What is the ratio of the Aid flow (current US$) of High income: nonOECD in 1989 to that in 1991?
Your answer should be compact. 0.82. What is the ratio of the Aid flow (current US$) of Argentina in 1989 to that in 1991?
Your answer should be compact. 1.4. What is the ratio of the Aid flow (current US$) of Central African Republic in 1989 to that in 1991?
Offer a very short reply. 1.02. What is the ratio of the Aid flow (current US$) of Sudan in 1989 to that in 1991?
Provide a short and direct response. 0.58. What is the ratio of the Aid flow (current US$) of High income: nonOECD in 1989 to that in 1992?
Make the answer very short. 0.55. What is the ratio of the Aid flow (current US$) in Argentina in 1989 to that in 1992?
Keep it short and to the point. 1.15. What is the ratio of the Aid flow (current US$) of Central African Republic in 1989 to that in 1992?
Your answer should be compact. 2.27. What is the ratio of the Aid flow (current US$) of Sudan in 1989 to that in 1992?
Your answer should be very brief. 1.02. What is the ratio of the Aid flow (current US$) in High income: nonOECD in 1990 to that in 1991?
Provide a succinct answer. 0.6. What is the ratio of the Aid flow (current US$) in Argentina in 1990 to that in 1991?
Your answer should be very brief. 1.2. What is the ratio of the Aid flow (current US$) in Central African Republic in 1990 to that in 1991?
Your answer should be compact. 0.65. What is the ratio of the Aid flow (current US$) in Sudan in 1990 to that in 1991?
Make the answer very short. 0.5. What is the ratio of the Aid flow (current US$) of High income: nonOECD in 1990 to that in 1992?
Provide a short and direct response. 0.4. What is the ratio of the Aid flow (current US$) in Argentina in 1990 to that in 1992?
Offer a very short reply. 0.99. What is the ratio of the Aid flow (current US$) of Central African Republic in 1990 to that in 1992?
Give a very brief answer. 1.45. What is the ratio of the Aid flow (current US$) in Sudan in 1990 to that in 1992?
Your answer should be very brief. 0.88. What is the ratio of the Aid flow (current US$) in High income: nonOECD in 1991 to that in 1992?
Make the answer very short. 0.67. What is the ratio of the Aid flow (current US$) in Argentina in 1991 to that in 1992?
Give a very brief answer. 0.82. What is the ratio of the Aid flow (current US$) in Central African Republic in 1991 to that in 1992?
Keep it short and to the point. 2.23. What is the ratio of the Aid flow (current US$) in Sudan in 1991 to that in 1992?
Provide a succinct answer. 1.77. What is the difference between the highest and the second highest Aid flow (current US$) of High income: nonOECD?
Your answer should be very brief. 6.50e+06. What is the difference between the highest and the second highest Aid flow (current US$) in Argentina?
Ensure brevity in your answer.  3.40e+05. What is the difference between the highest and the second highest Aid flow (current US$) of Sudan?
Provide a short and direct response. 5.55e+06. What is the difference between the highest and the lowest Aid flow (current US$) of High income: nonOECD?
Keep it short and to the point. 1.18e+07. What is the difference between the highest and the lowest Aid flow (current US$) in Argentina?
Give a very brief answer. 7.80e+05. What is the difference between the highest and the lowest Aid flow (current US$) of Sudan?
Offer a very short reply. 1.03e+07. 